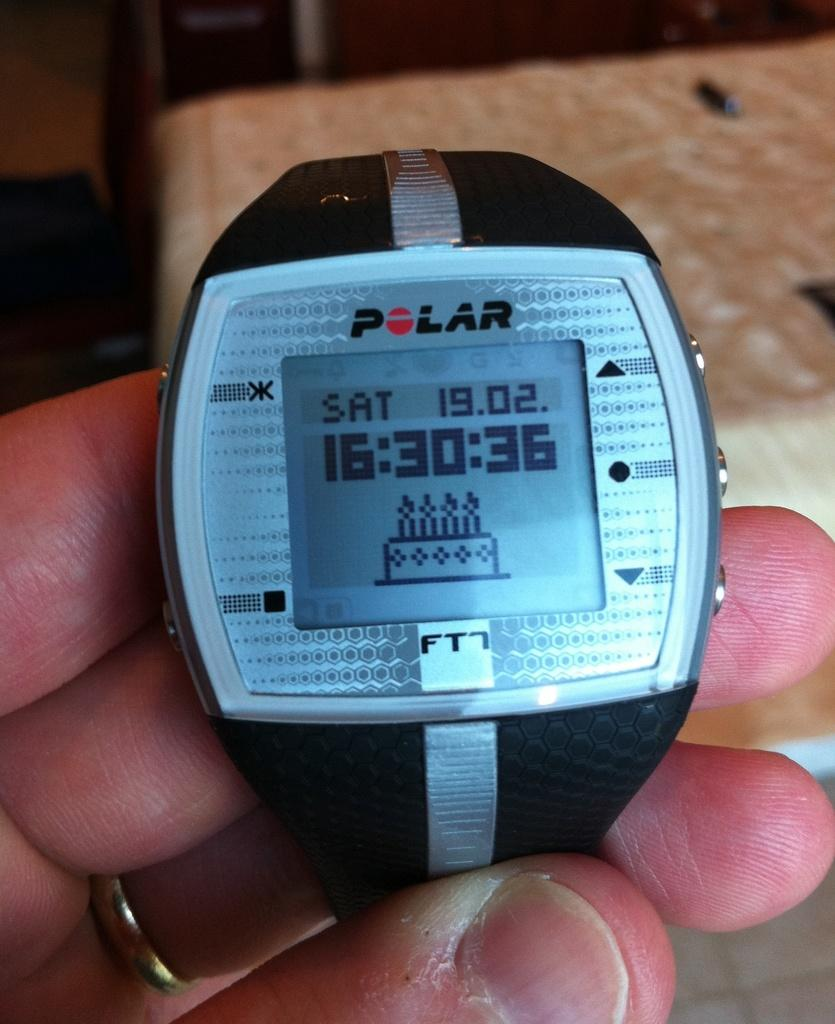<image>
Summarize the visual content of the image. A watch that has a birthday cake on it which is the brand polar. 